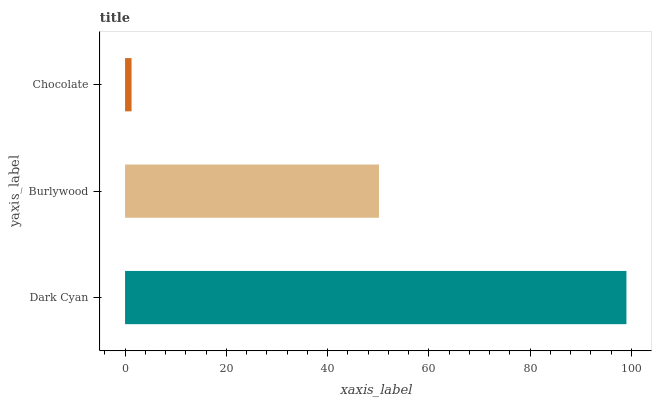Is Chocolate the minimum?
Answer yes or no. Yes. Is Dark Cyan the maximum?
Answer yes or no. Yes. Is Burlywood the minimum?
Answer yes or no. No. Is Burlywood the maximum?
Answer yes or no. No. Is Dark Cyan greater than Burlywood?
Answer yes or no. Yes. Is Burlywood less than Dark Cyan?
Answer yes or no. Yes. Is Burlywood greater than Dark Cyan?
Answer yes or no. No. Is Dark Cyan less than Burlywood?
Answer yes or no. No. Is Burlywood the high median?
Answer yes or no. Yes. Is Burlywood the low median?
Answer yes or no. Yes. Is Dark Cyan the high median?
Answer yes or no. No. Is Dark Cyan the low median?
Answer yes or no. No. 